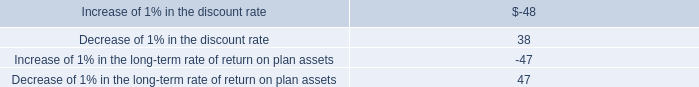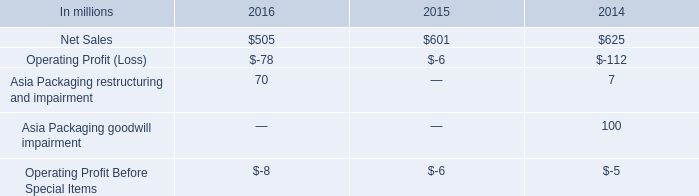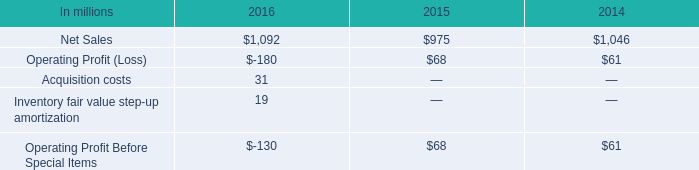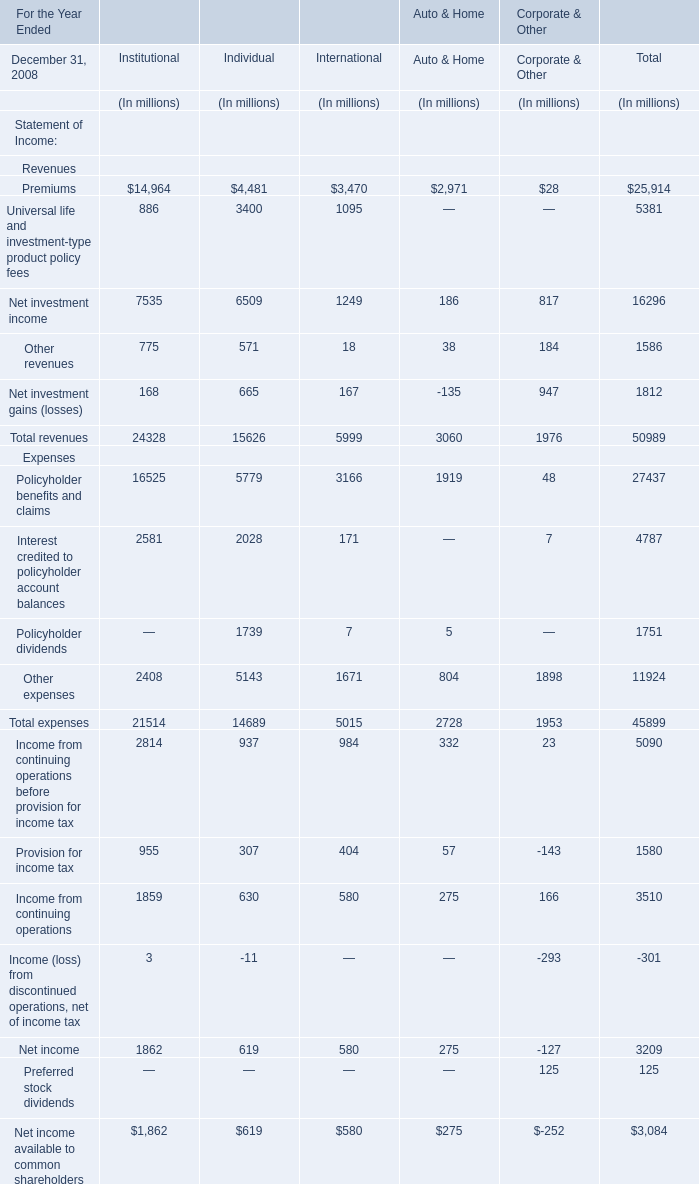Which element for Total exceeds 30 % of total in 2008? 
Answer: Premiums, Net investment income. 